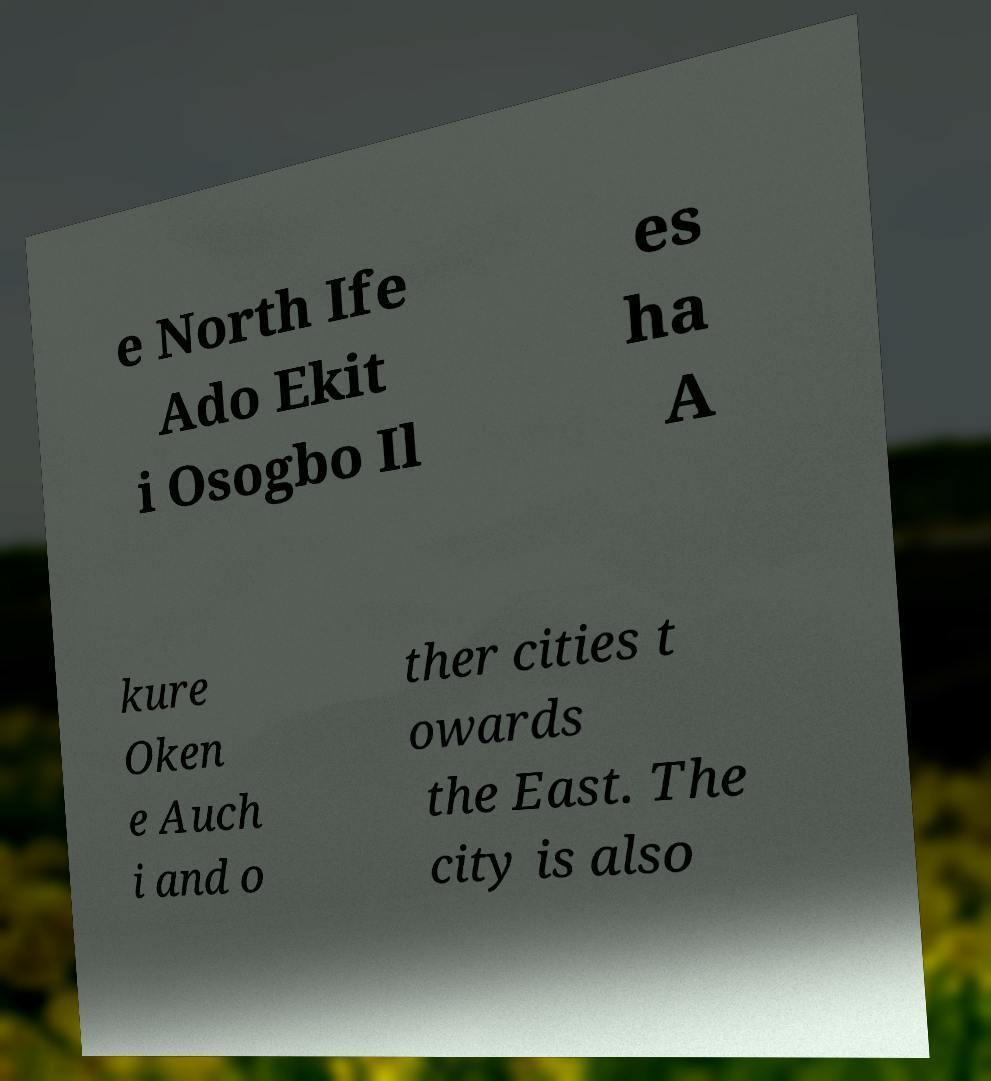Please read and relay the text visible in this image. What does it say? e North Ife Ado Ekit i Osogbo Il es ha A kure Oken e Auch i and o ther cities t owards the East. The city is also 